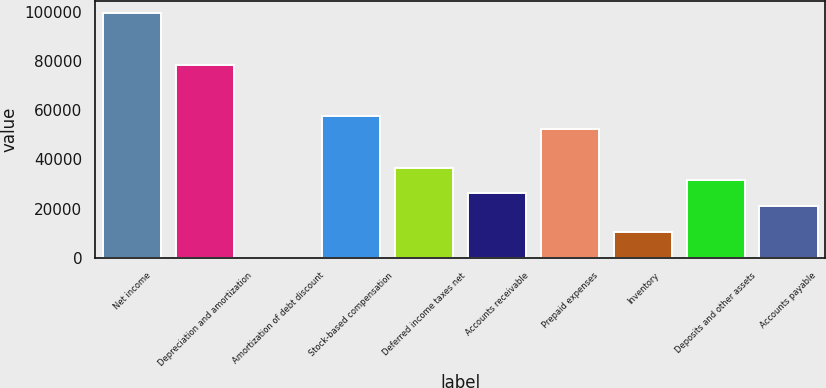Convert chart to OTSL. <chart><loc_0><loc_0><loc_500><loc_500><bar_chart><fcel>Net income<fcel>Depreciation and amortization<fcel>Amortization of debt discount<fcel>Stock-based compensation<fcel>Deferred income taxes net<fcel>Accounts receivable<fcel>Prepaid expenses<fcel>Inventory<fcel>Deposits and other assets<fcel>Accounts payable<nl><fcel>99274.3<fcel>78407.5<fcel>157<fcel>57540.7<fcel>36673.9<fcel>26240.5<fcel>52324<fcel>10590.4<fcel>31457.2<fcel>21023.8<nl></chart> 